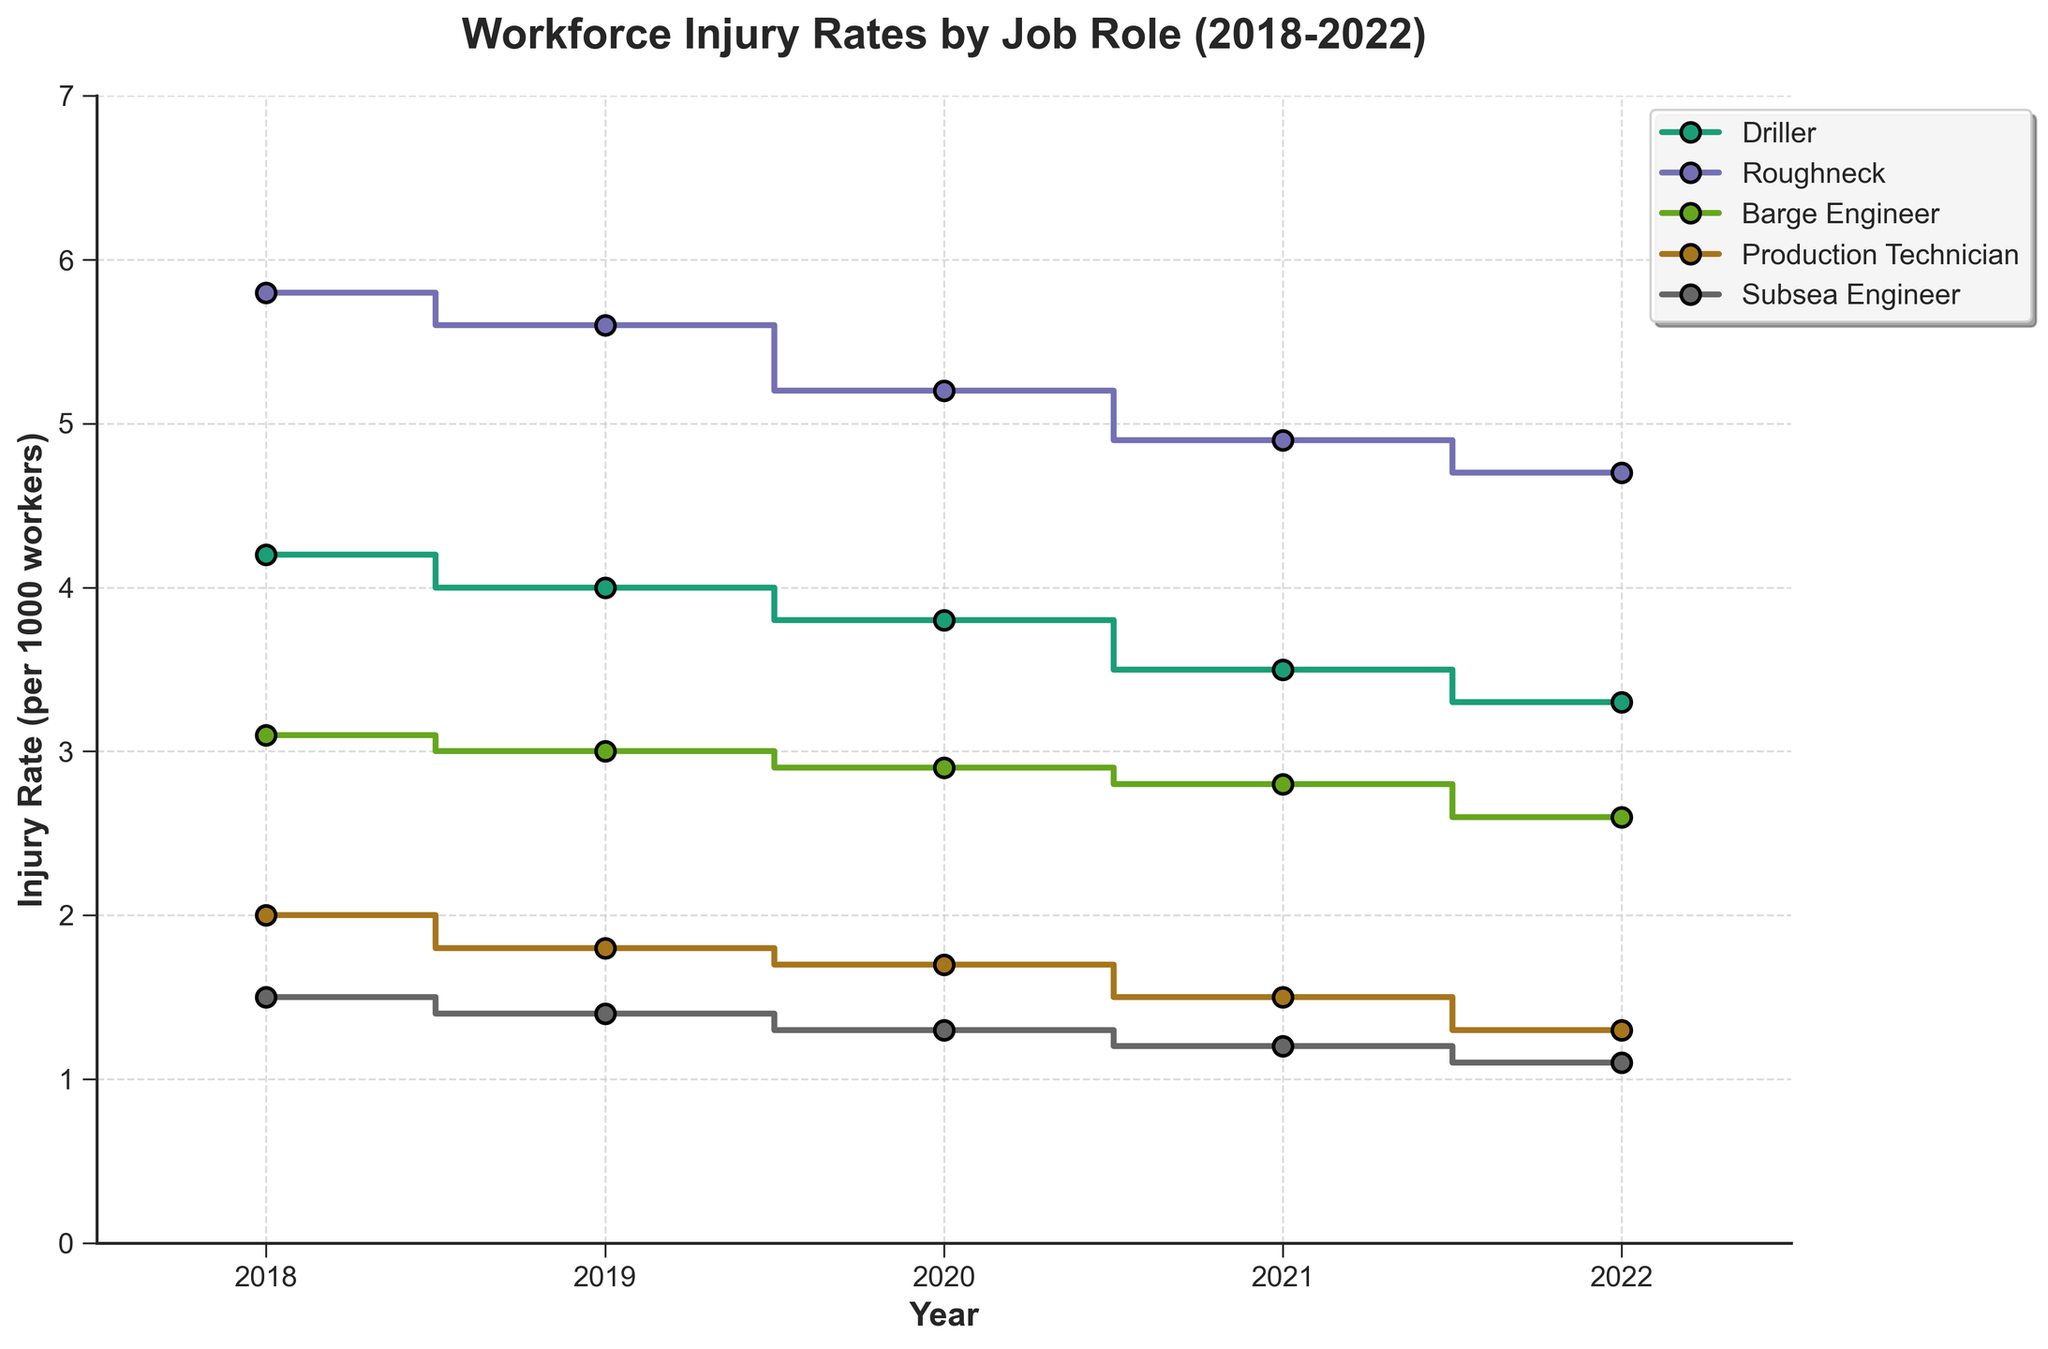What is the title of the figure? The title is typically found at the top of the figure, and it summarizes what the figure is about. In this case, it is "Workforce Injury Rates by Job Role (2018-2022)".
Answer: Workforce Injury Rates by Job Role (2018-2022) What is the injury rate for Drillers in 2020? Locate the step plot for Drillers, find the year 2020 on the x-axis, and read off the corresponding injury rate on the y-axis.
Answer: 3.8 Which job role had the lowest injury rate in 2022? Look at the y-axis values for all job roles in 2022. The role corresponding to the lowest point on the plot for that year is the one with the lowest injury rate.
Answer: Subsea Engineer How did the injury rate for Roughnecks change from 2018 to 2022? First, find the injury rates for Roughnecks in 2018 and 2022 from the y-axis values. Then, calculate the difference between these two values. The change is a decrease if the 2022 value is lower.
Answer: Decreased by 1.1 Which job role experienced the greatest decrease in injury rate from 2018 to 2022? For each job role, calculate the difference in injury rate between 2018 and 2022. The greatest decrease is the largest positive difference among all roles.
Answer: Production Technician What is the average injury rate for Barge Engineers over the 5-year period? Sum the injury rates for Barge Engineers from 2018 to 2022 and divide by the number of years (5).
Answer: 2.88 How does the injury rate of Subsea Engineers in 2021 compare to that in 2019? Locate the injury rates for Subsea Engineers for 2021 and 2019 and compare their y-axis values to determine if it is greater, less, or the same.
Answer: Less by 0.2 Which job role consistently had the highest injury rate from 2018 to 2022? Compare the injury rates for all job roles across all years. Identify the role with the highest y-axis values each year.
Answer: Roughneck Identify a trend in the injury rate for Production Technicians from 2018 to 2022. Look at the y-axis values for Production Technicians from 2018 to 2022. Determine if there is a noticeable increase, decrease, or other patterns over the years.
Answer: Decreasing trend In which year did Drillers experience the largest drop in injury rates compared to the previous year? For each year, calculate the difference in injury rates for Drillers compared to the previous year. The largest negative difference indicates the largest drop.
Answer: 2021 